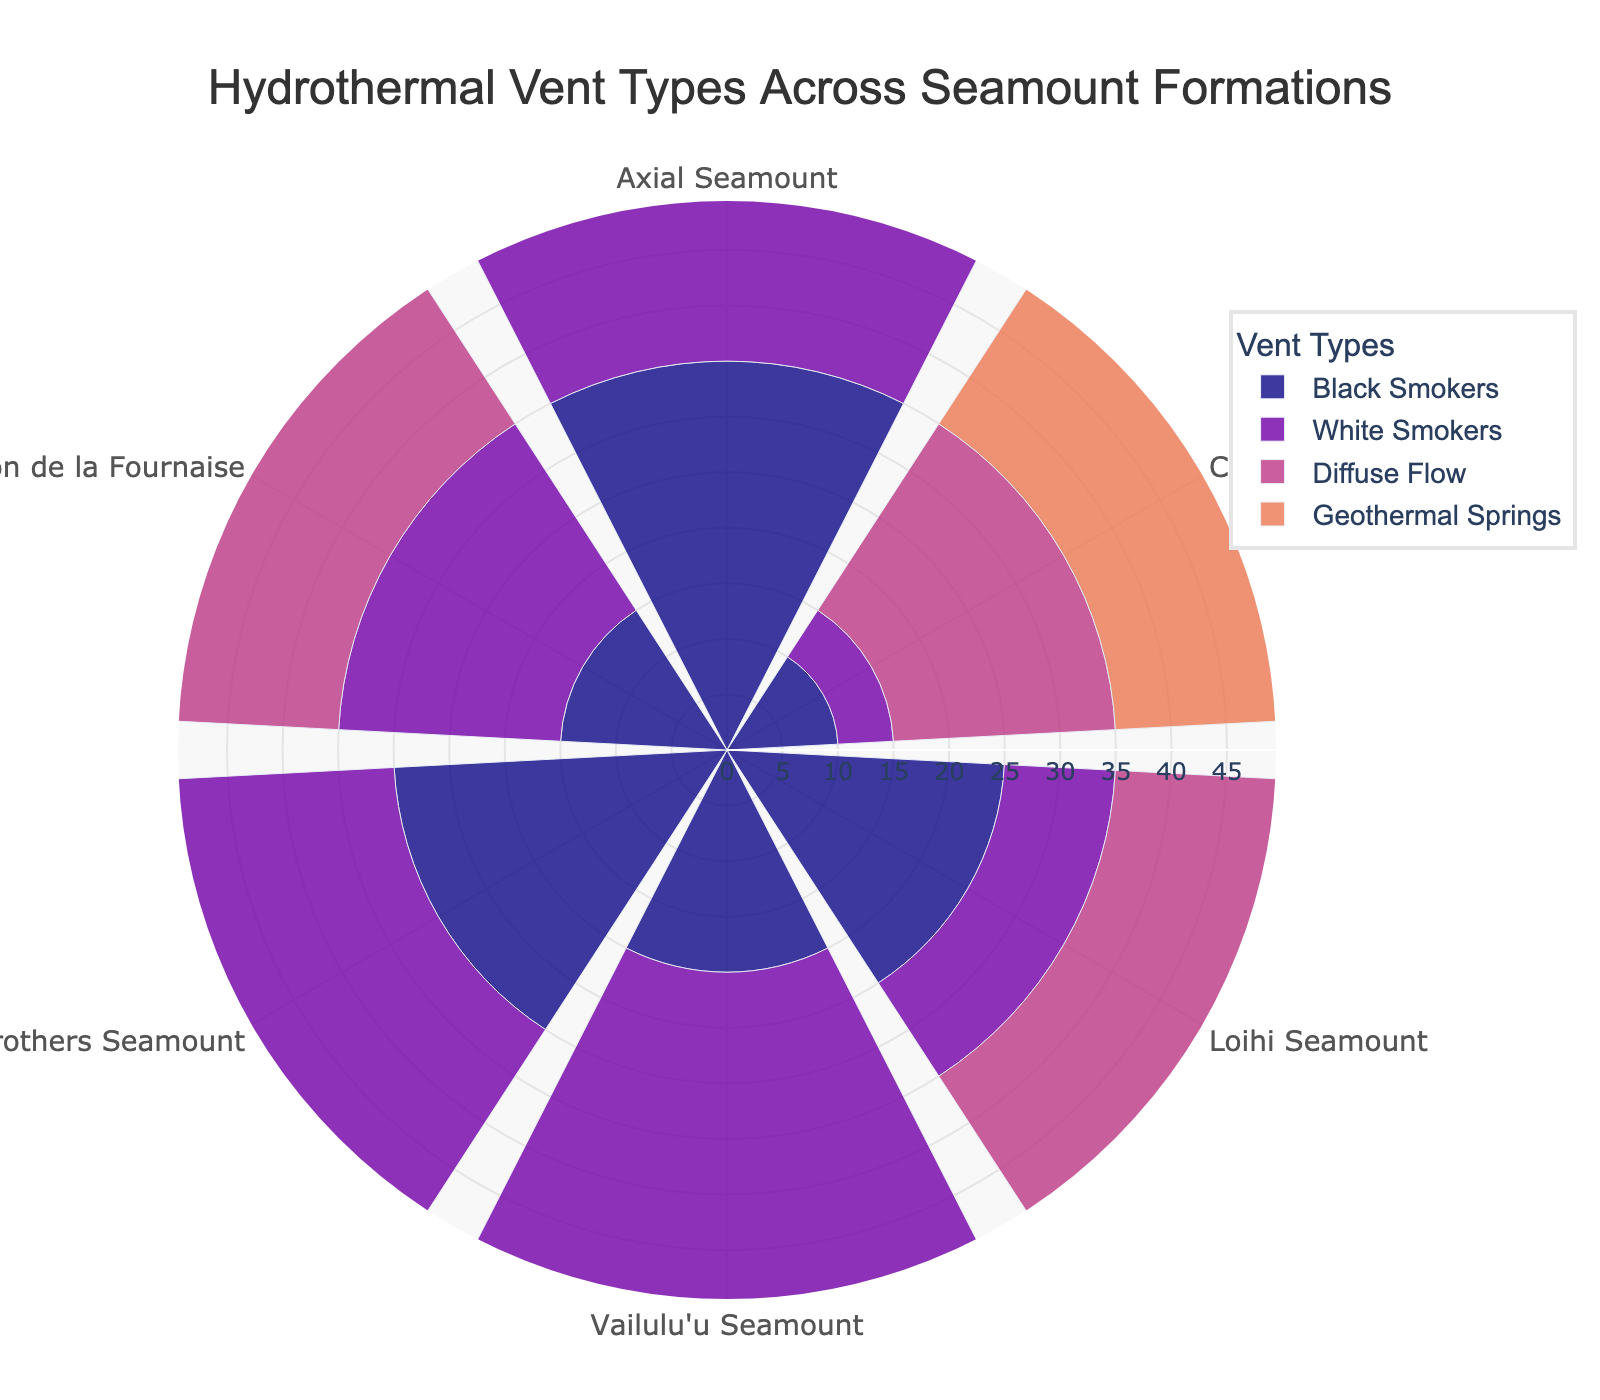What's the title of the chart? The title is located at the top center of the chart. From the given code, the title is 'Hydrothermal Vent Types Across Seamount Formations'.
Answer: Hydrothermal Vent Types Across Seamount Formations Which seamount formation has the highest number of White Smokers? We need to find the seamount formation with the highest bar for the 'White Smokers' category. From the data, the highest value for White Smokers is 45 at Axial Seamount.
Answer: Axial Seamount What is the total number of Geothermal Springs across all formations? Summing the values for Geothermal Springs across all formations: 20 (Axial) + 15 (Cobb) + 10 (Loihi) + 15 (Vailulu'u) + 25 (Brothers) + 20 (Piton de la Fournaise) = 105.
Answer: 105 How does the number of Black Smokers in Cobb Seamount compare to those in Axial Seamount? Comparing values: Cobb Seamount has 10 Black Smokers, while Axial Seamount has 35 Black Smokers. Axial Seamount has more by 25.
Answer: Axial Seamount has 25 more Which vent type is the most frequent on Brothers Seamount? For Brothers Seamount, the highest value among the vent types is for Diffuse Flow, which is 40.
Answer: Diffuse Flow Is the number of Diffuse Flow vents higher in Piton de la Fournaise or Vailulu'u Seamount? Comparing values: Piton de la Fournaise has 35 Diffuse Flow vents, while Vailulu'u Seamount has 25. Piton de la Fournaise has more.
Answer: Piton de la Fournaise What's the average number of White Smokers across all formations? Calculating average number: (45 + 5 + 10 + 30 + 35 + 20) / 6 = 145 / 6 ≈ 24.17.
Answer: 24.17 Which seamount formation has the lowest number of Black Smokers? From the data, the lowest number of Black Smokers is at Cobb Seamount with 10.
Answer: Cobb Seamount How does the frequency of Geothermal Springs in Loihi Seamount compare to that in Brothers Seamount? Loihi Seamount has 10 Geothermal Springs, while Brothers Seamount has 25. Brothers Seamount has more by 15.
Answer: Brothers Seamount has 15 more What is the range of the radial axis? The range of the radial axis is set from 0 to slightly above the maximum value in the data. The maximum value is 45, so the range is up to around 50 as given by max(values.max(axis=0))*1.1 in the code.
Answer: 0 to 50 